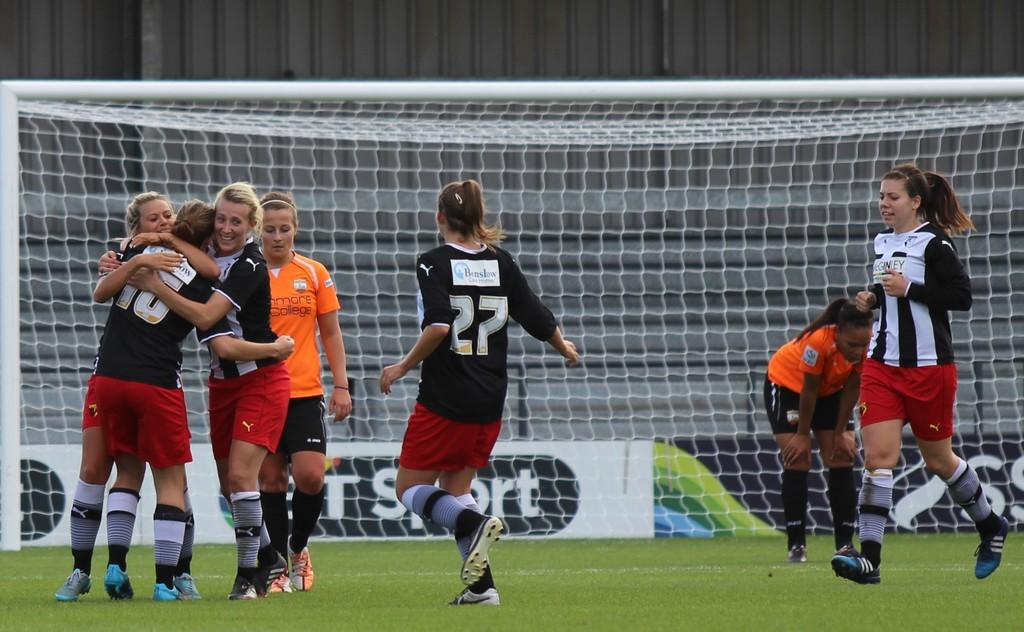Provide a one-sentence caption for the provided image. Two teams of young girls including player number 27 are playing a soccer match. 